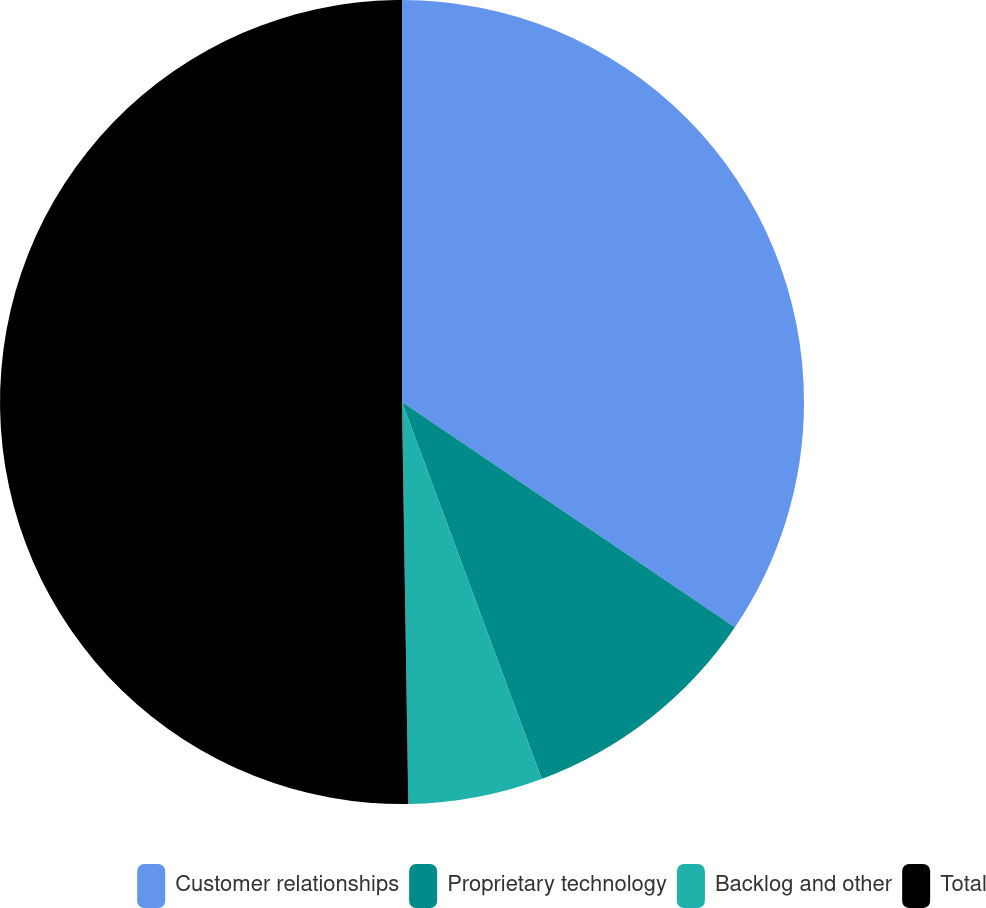Convert chart to OTSL. <chart><loc_0><loc_0><loc_500><loc_500><pie_chart><fcel>Customer relationships<fcel>Proprietary technology<fcel>Backlog and other<fcel>Total<nl><fcel>34.47%<fcel>9.88%<fcel>5.4%<fcel>50.25%<nl></chart> 